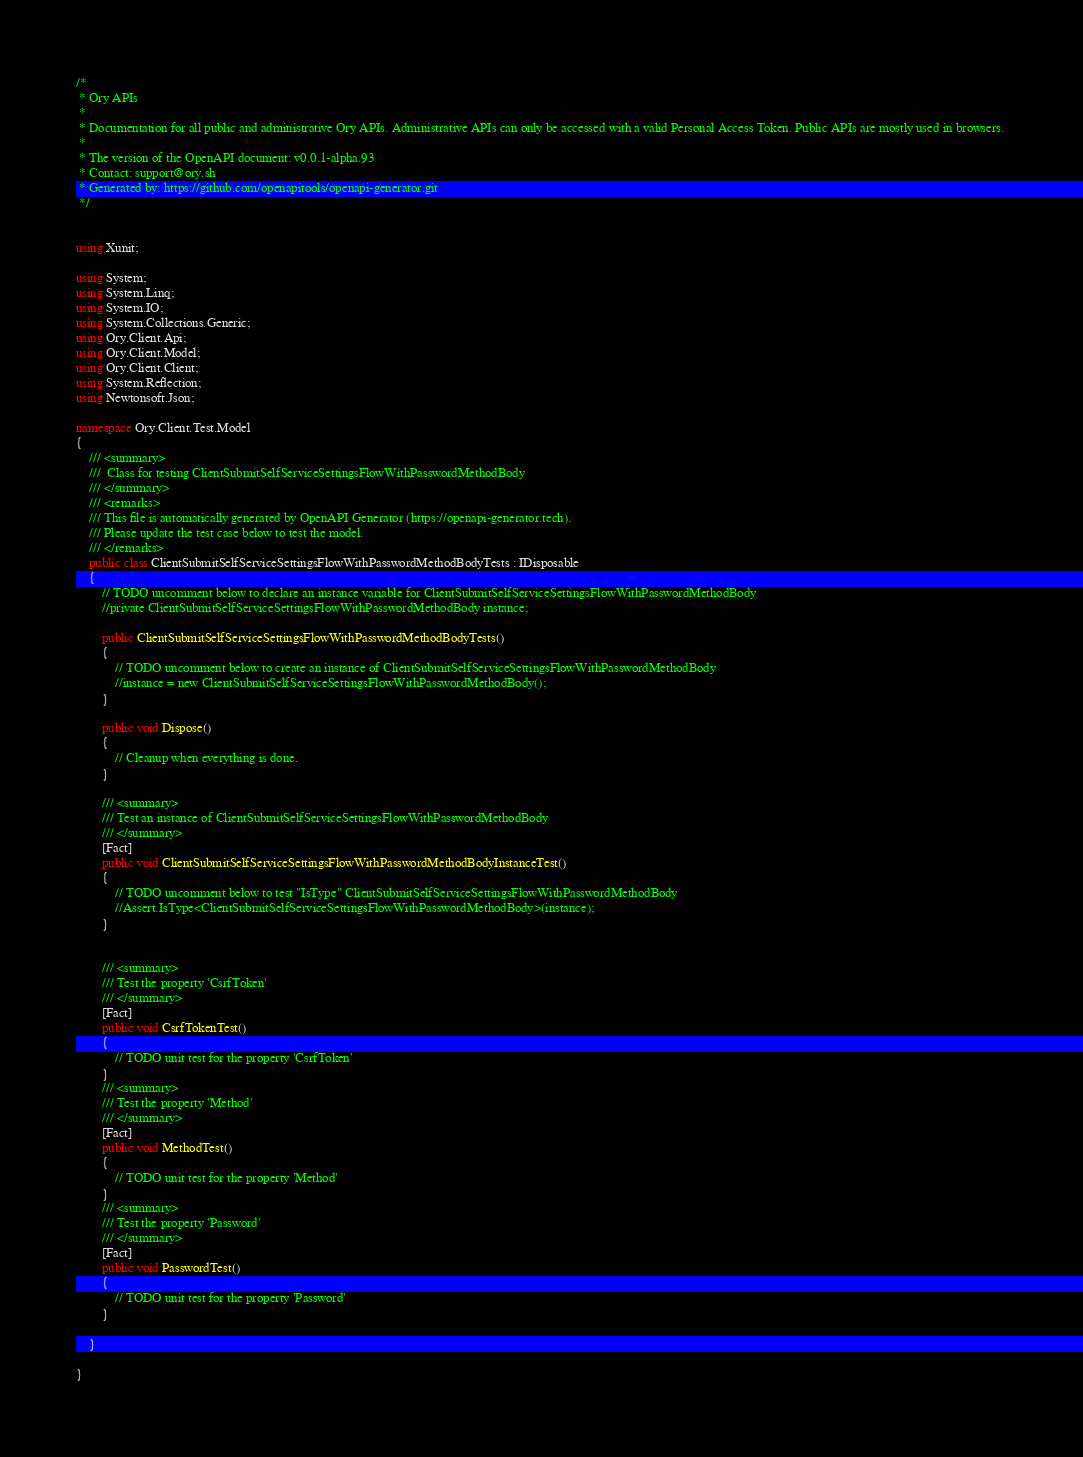Convert code to text. <code><loc_0><loc_0><loc_500><loc_500><_C#_>/*
 * Ory APIs
 *
 * Documentation for all public and administrative Ory APIs. Administrative APIs can only be accessed with a valid Personal Access Token. Public APIs are mostly used in browsers. 
 *
 * The version of the OpenAPI document: v0.0.1-alpha.93
 * Contact: support@ory.sh
 * Generated by: https://github.com/openapitools/openapi-generator.git
 */


using Xunit;

using System;
using System.Linq;
using System.IO;
using System.Collections.Generic;
using Ory.Client.Api;
using Ory.Client.Model;
using Ory.Client.Client;
using System.Reflection;
using Newtonsoft.Json;

namespace Ory.Client.Test.Model
{
    /// <summary>
    ///  Class for testing ClientSubmitSelfServiceSettingsFlowWithPasswordMethodBody
    /// </summary>
    /// <remarks>
    /// This file is automatically generated by OpenAPI Generator (https://openapi-generator.tech).
    /// Please update the test case below to test the model.
    /// </remarks>
    public class ClientSubmitSelfServiceSettingsFlowWithPasswordMethodBodyTests : IDisposable
    {
        // TODO uncomment below to declare an instance variable for ClientSubmitSelfServiceSettingsFlowWithPasswordMethodBody
        //private ClientSubmitSelfServiceSettingsFlowWithPasswordMethodBody instance;

        public ClientSubmitSelfServiceSettingsFlowWithPasswordMethodBodyTests()
        {
            // TODO uncomment below to create an instance of ClientSubmitSelfServiceSettingsFlowWithPasswordMethodBody
            //instance = new ClientSubmitSelfServiceSettingsFlowWithPasswordMethodBody();
        }

        public void Dispose()
        {
            // Cleanup when everything is done.
        }

        /// <summary>
        /// Test an instance of ClientSubmitSelfServiceSettingsFlowWithPasswordMethodBody
        /// </summary>
        [Fact]
        public void ClientSubmitSelfServiceSettingsFlowWithPasswordMethodBodyInstanceTest()
        {
            // TODO uncomment below to test "IsType" ClientSubmitSelfServiceSettingsFlowWithPasswordMethodBody
            //Assert.IsType<ClientSubmitSelfServiceSettingsFlowWithPasswordMethodBody>(instance);
        }


        /// <summary>
        /// Test the property 'CsrfToken'
        /// </summary>
        [Fact]
        public void CsrfTokenTest()
        {
            // TODO unit test for the property 'CsrfToken'
        }
        /// <summary>
        /// Test the property 'Method'
        /// </summary>
        [Fact]
        public void MethodTest()
        {
            // TODO unit test for the property 'Method'
        }
        /// <summary>
        /// Test the property 'Password'
        /// </summary>
        [Fact]
        public void PasswordTest()
        {
            // TODO unit test for the property 'Password'
        }

    }

}
</code> 